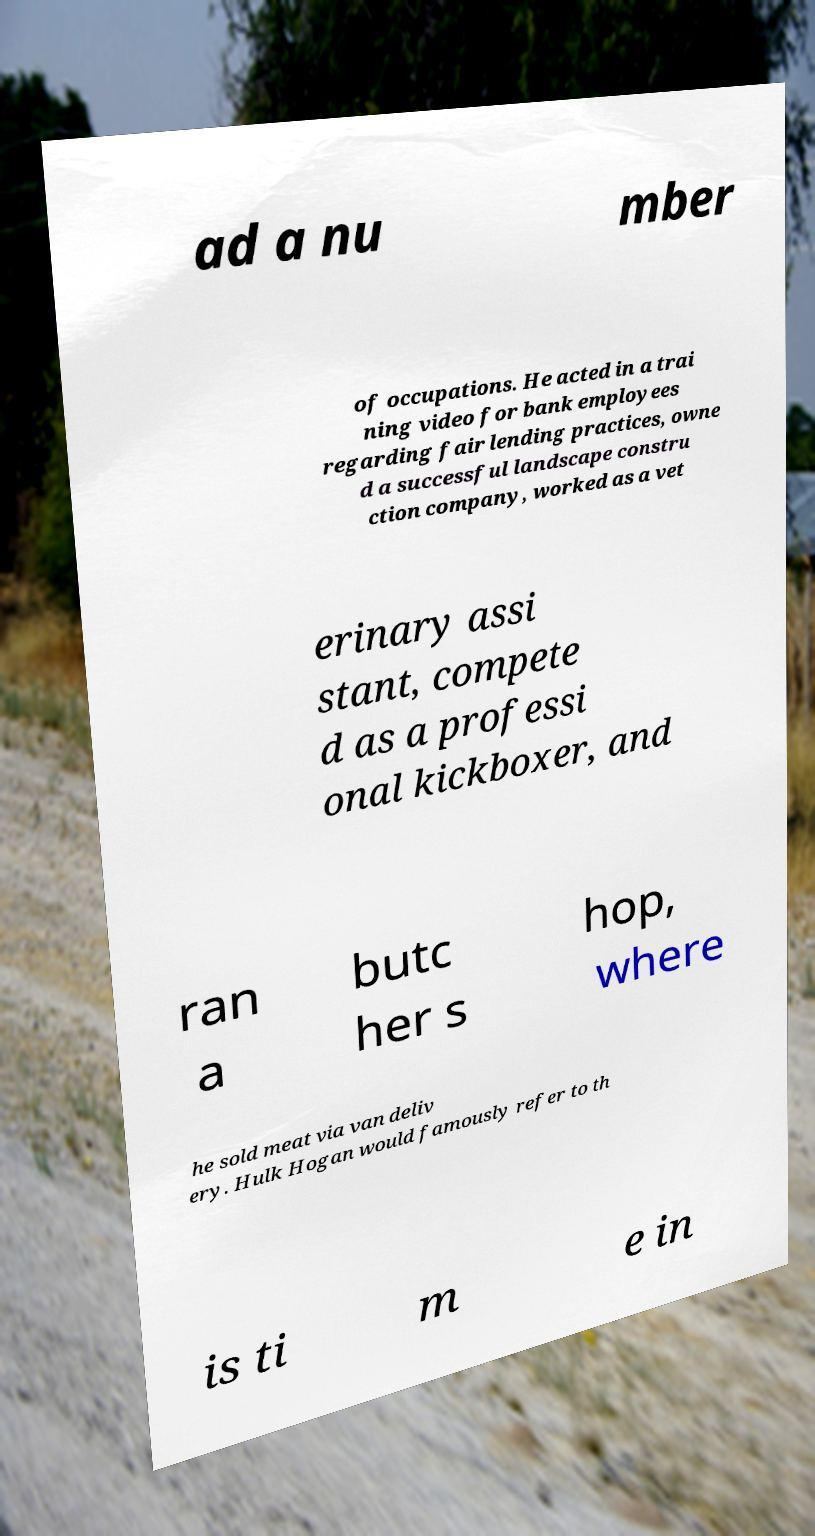For documentation purposes, I need the text within this image transcribed. Could you provide that? ad a nu mber of occupations. He acted in a trai ning video for bank employees regarding fair lending practices, owne d a successful landscape constru ction company, worked as a vet erinary assi stant, compete d as a professi onal kickboxer, and ran a butc her s hop, where he sold meat via van deliv ery. Hulk Hogan would famously refer to th is ti m e in 